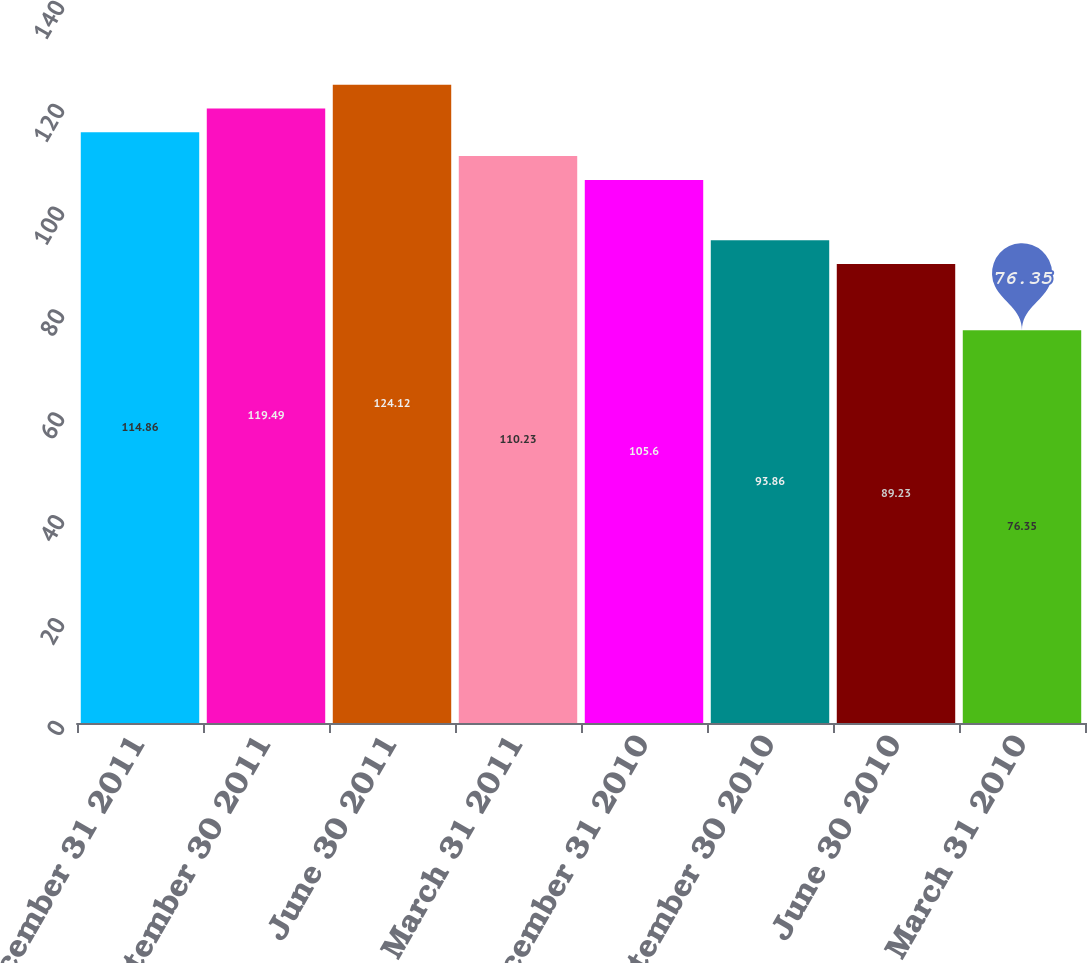Convert chart to OTSL. <chart><loc_0><loc_0><loc_500><loc_500><bar_chart><fcel>December 31 2011<fcel>September 30 2011<fcel>June 30 2011<fcel>March 31 2011<fcel>December 31 2010<fcel>September 30 2010<fcel>June 30 2010<fcel>March 31 2010<nl><fcel>114.86<fcel>119.49<fcel>124.12<fcel>110.23<fcel>105.6<fcel>93.86<fcel>89.23<fcel>76.35<nl></chart> 